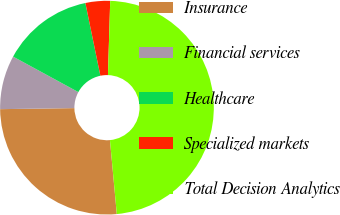Convert chart. <chart><loc_0><loc_0><loc_500><loc_500><pie_chart><fcel>Insurance<fcel>Financial services<fcel>Healthcare<fcel>Specialized markets<fcel>Total Decision Analytics<nl><fcel>26.24%<fcel>8.15%<fcel>13.83%<fcel>3.72%<fcel>48.04%<nl></chart> 